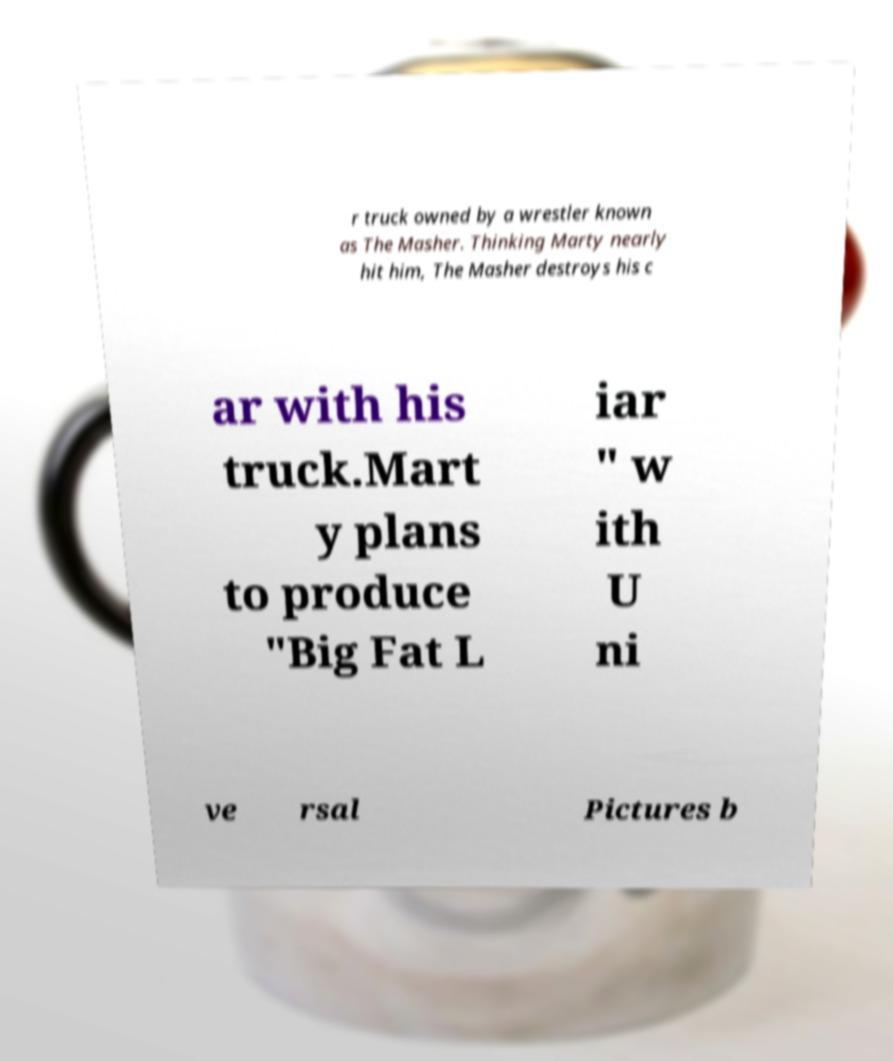Please identify and transcribe the text found in this image. r truck owned by a wrestler known as The Masher. Thinking Marty nearly hit him, The Masher destroys his c ar with his truck.Mart y plans to produce "Big Fat L iar " w ith U ni ve rsal Pictures b 